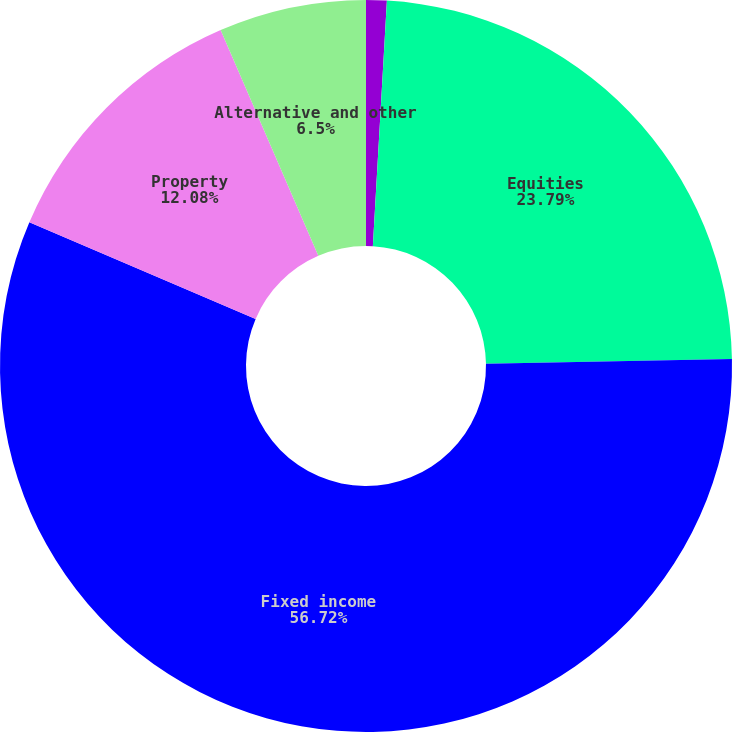<chart> <loc_0><loc_0><loc_500><loc_500><pie_chart><fcel>Cash and cash equivalents<fcel>Equities<fcel>Fixed income<fcel>Property<fcel>Alternative and other<nl><fcel>0.91%<fcel>23.79%<fcel>56.72%<fcel>12.08%<fcel>6.5%<nl></chart> 